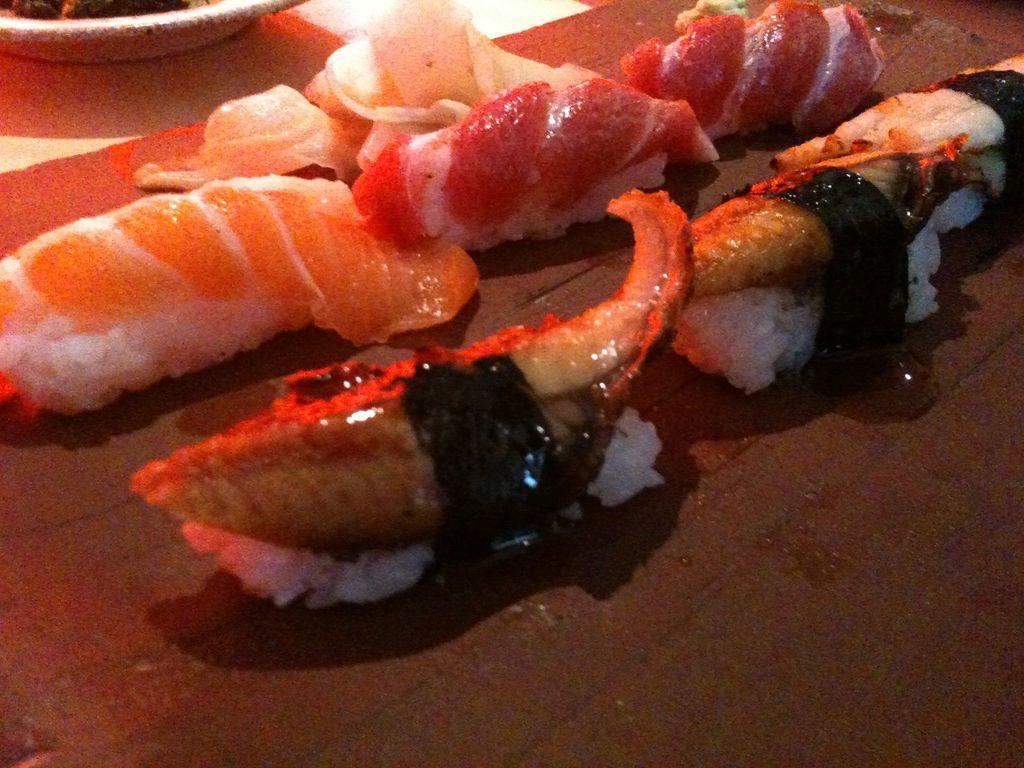Could you give a brief overview of what you see in this image? In this image we can see food items on a platform. On the left side at the top we can see item in a plate on a platform. 